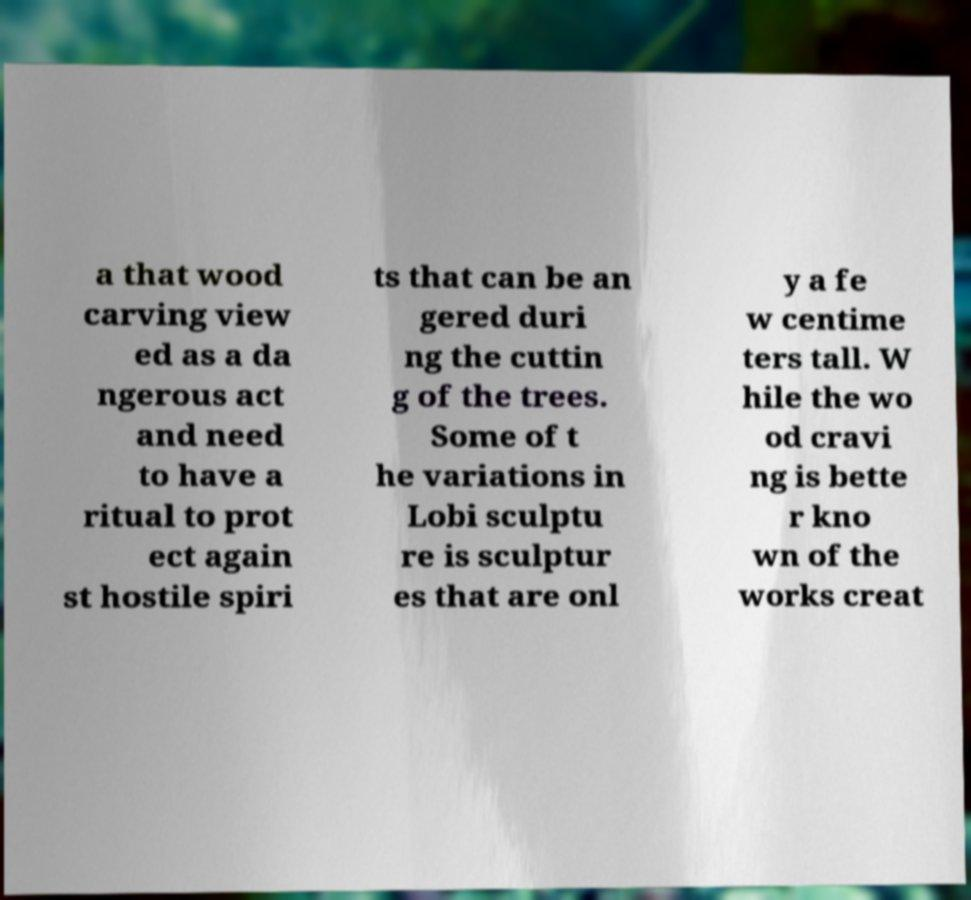Please identify and transcribe the text found in this image. a that wood carving view ed as a da ngerous act and need to have a ritual to prot ect again st hostile spiri ts that can be an gered duri ng the cuttin g of the trees. Some of t he variations in Lobi sculptu re is sculptur es that are onl y a fe w centime ters tall. W hile the wo od cravi ng is bette r kno wn of the works creat 